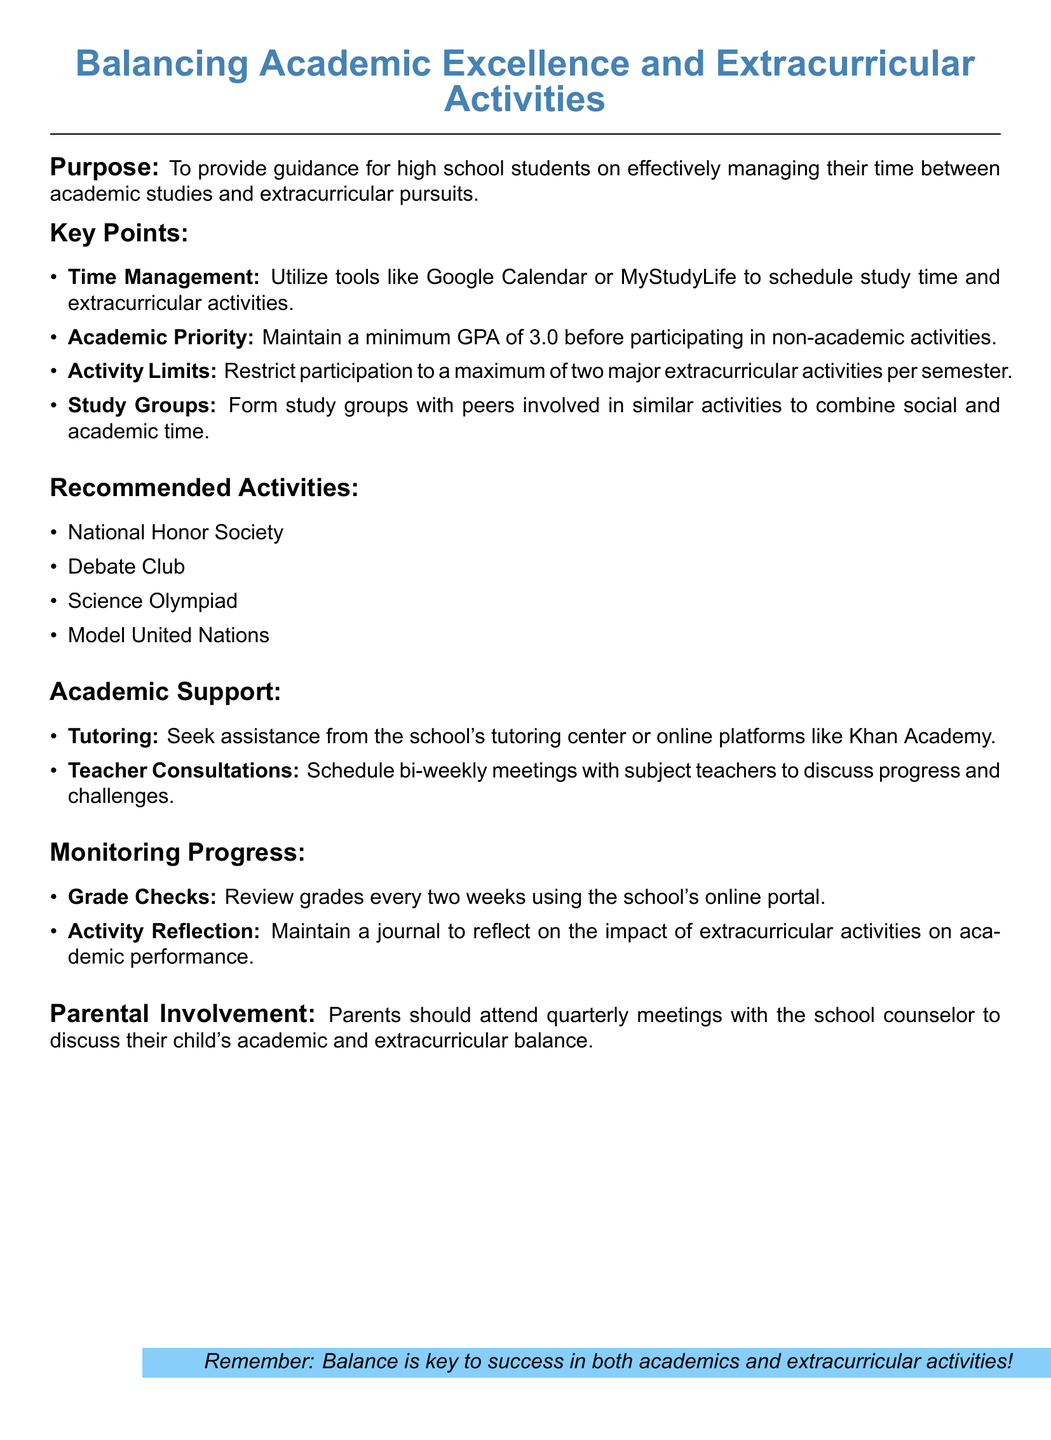What is the minimum GPA required before participating in non-academic activities? The minimum GPA required is stated as part of the academic priority guidelines in the document.
Answer: 3.0 What are two recommended activities listed in the document? The document lists several recommended activities for students, two of which can be identified.
Answer: National Honor Society, Debate Club How often should parents attend meetings with the school counselor? The document specifies the frequency of parental involvement with school counseling.
Answer: Quarterly What tools are suggested for scheduling study time? The document provides specific tools for time management that students can use.
Answer: Google Calendar, MyStudyLife What is the maximum number of major extracurricular activities allowed per semester? The document specifies a restriction on participation in major extracurricular activities for students.
Answer: Two 